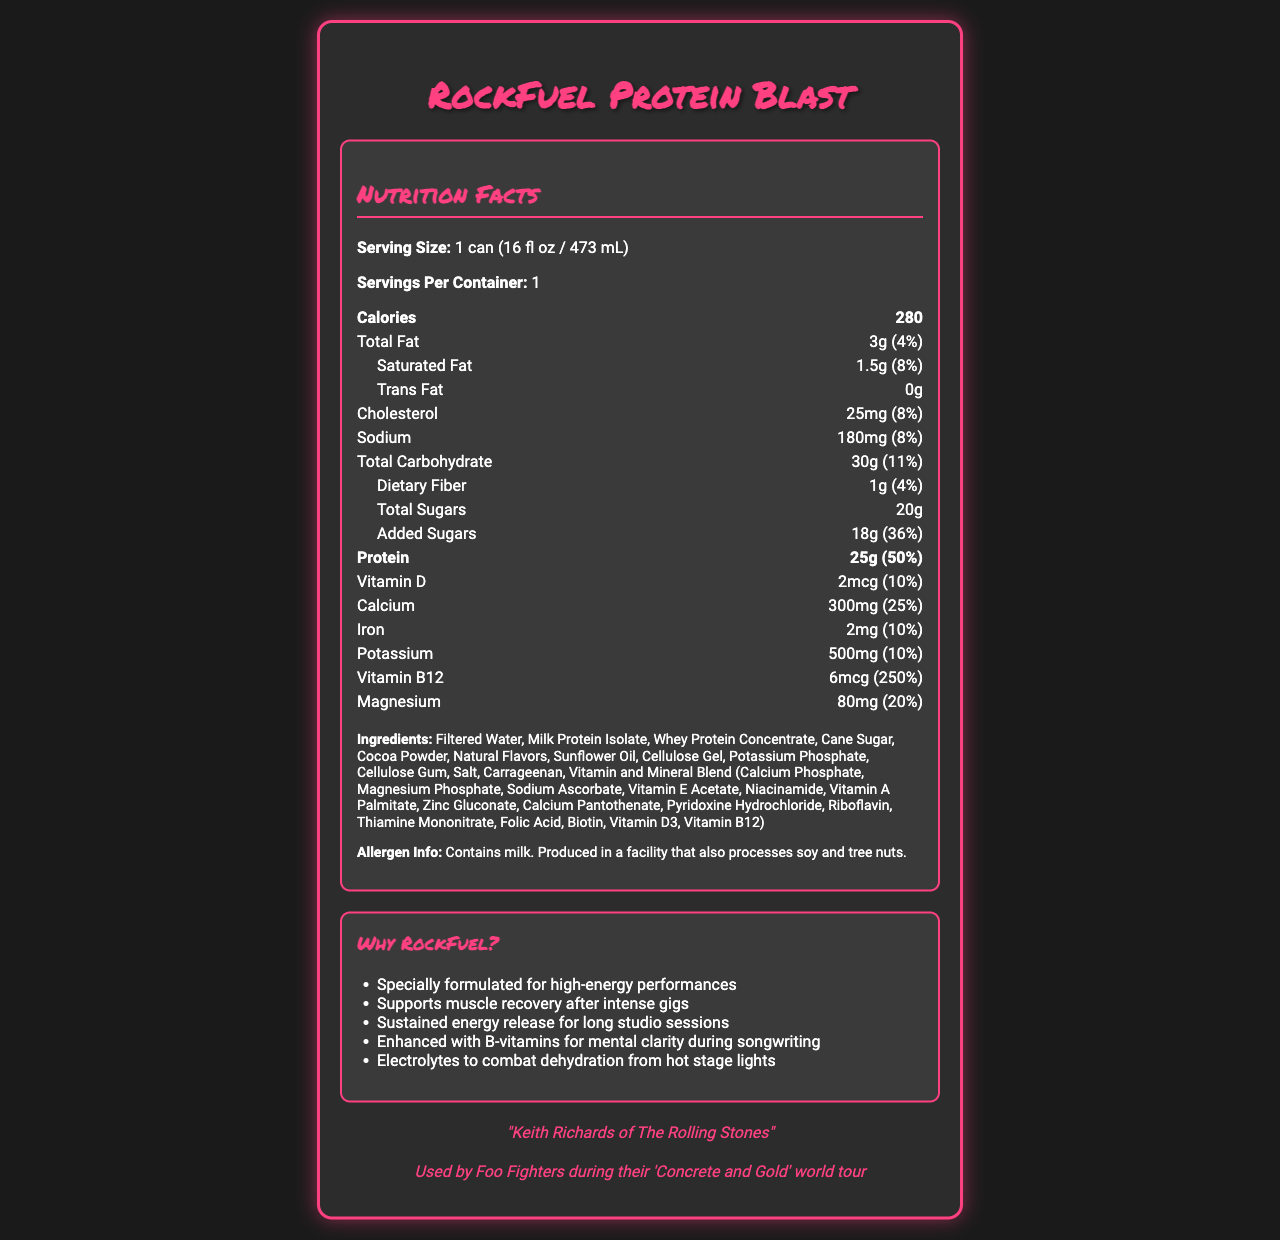what is the serving size of RockFuel Protein Blast? The document specifies the serving size as "1 can (16 fl oz / 473 mL)".
Answer: 1 can (16 fl oz / 473 mL) how many calories are in one serving? The document shows that each serving has 280 calories.
Answer: 280 what is the percentage daily value of protein in the energy drink? The document lists the daily value percentage of protein as 50%.
Answer: 50% what kinds of fats are present in the drink, and in what amounts? The document specifies total fat as 3g with 4% daily value, saturated fat as 1.5g with 8% daily value, and lists trans fat as 0g.
Answer: Total Fat: 3g (4%), Saturated Fat: 1.5g (8%), Trans Fat: 0g identify one ingredient that might cause an allergic reaction. The ingredient list notes that the product contains milk, which is a common allergen.
Answer: Milk how much vitamin B12 is in RockFuel Protein Blast? The document indicates that there are 6mcg of vitamin B12 in the drink.
Answer: 6mcg what is the purpose of electrolytes in this energy drink? One of the marketing claims states that electrolytes are included to combat dehydration from hot stage lights.
Answer: To combat dehydration from hot stage lights which famous musician endorses RockFuel Protein Blast? A. Keith Richards B. Mick Jagger C. Dave Grohl The endorsement is listed as "Keith Richards of The Rolling Stones".
Answer: A what is the sodium content in one can of RockFuel Protein Blast? The document shows that there are 180mg of sodium in one serving of the drink.
Answer: 180mg is soy one of the ingredients listed? Soy is not listed among the ingredients, though the product is processed in a facility that also processes soy.
Answer: No which of the following is a marketing claim made about RockFuel Protein Blast? I. Enhances muscle strength II. Supports muscle recovery after intense gigs III. Promotes weight loss A. I only B. II only C. I and III only D. II and III only The document includes "Supports muscle recovery after intense gigs" as one of its claims whereas the other two claims are not mentioned.
Answer: B what is the potassium daily value percentage provided by this energy drink? The document lists potassium with a daily value percentage of 10%.
Answer: 10% what flavors are used in this energy drink? The ingredient list mentions 'Natural Flavors' as one of the components.
Answer: Natural Flavors do musicians on the Foo Fighters' 'Concrete and Gold' world tour use this product? The document states that the product was "used by Foo Fighters during their 'Concrete and Gold' world tour."
Answer: Yes what is the main idea of the document? The document focuses on providing detailed information about RockFuel Protein Blast, its nutritional content, marketing claims for its benefits to musicians, endorsements, and allergen information.
Answer: RockFuel Protein Blast is a high-protein energy drink formulated for musicians with specific nutritional benefits, endorsements, and usage claims. It includes detailed nutritional information and marketing claims such as muscle recovery support and sustained energy. what is the price of RockFuel Protein Blast? The document does not provide any details regarding the price of the energy drink.
Answer: Not enough information 